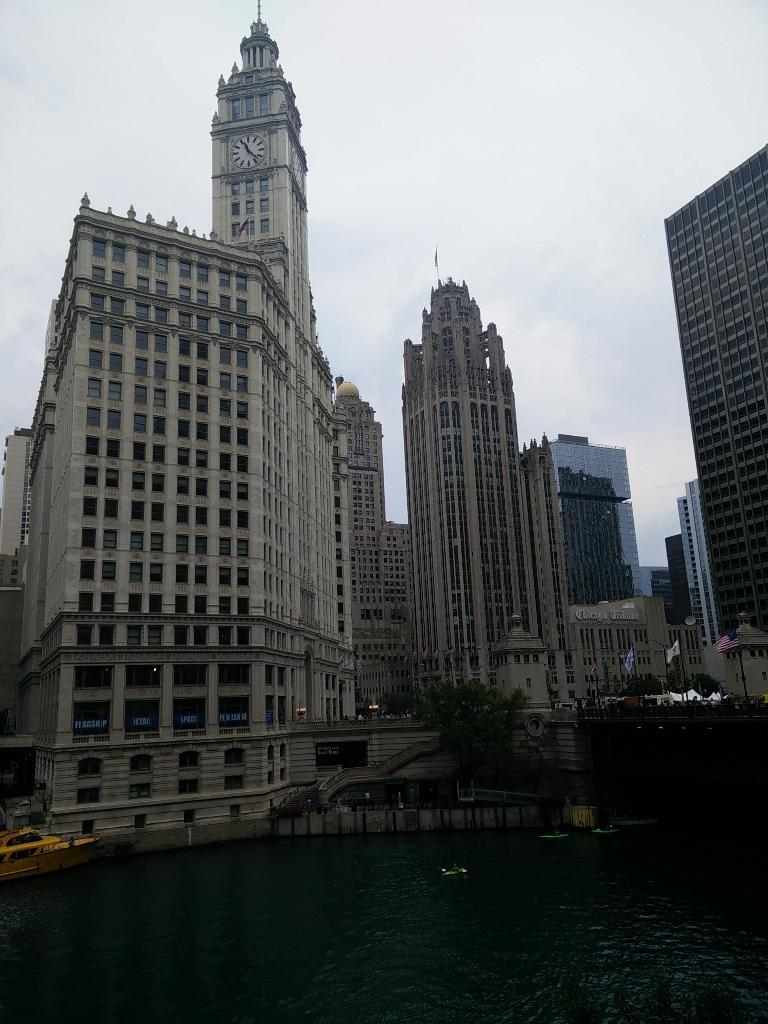What type of structures are present in the image? There are buildings in the image. What feature do the buildings have? The buildings have windows. Can you describe a specific architectural element in the image? There is a tower with a clock in the image. What natural feature can be seen in the image? There is a lake in the image. What is located on the water at the left side of the image? There is a boat on the water at the left side of the image. How would you describe the weather based on the image? The sky is clear in the image. How many fingers can be seen holding a twig in the image? There are no fingers or twigs present in the image. Is there a scarecrow standing near the lake in the image? There is no scarecrow present in the image. 